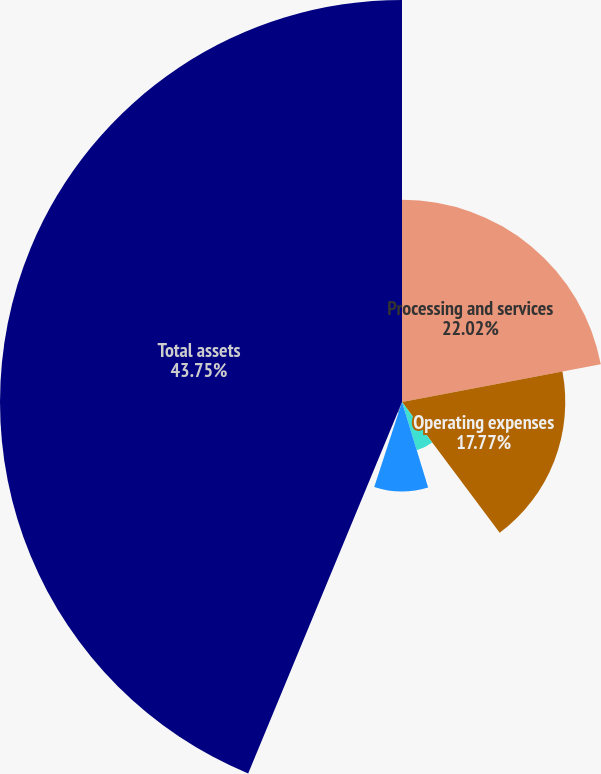<chart> <loc_0><loc_0><loc_500><loc_500><pie_chart><fcel>Processing and services<fcel>Operating expenses<fcel>Operating income<fcel>Depreciation and amortization<fcel>Capital expenditures<fcel>Total assets<nl><fcel>22.02%<fcel>17.77%<fcel>5.49%<fcel>9.74%<fcel>1.23%<fcel>43.75%<nl></chart> 